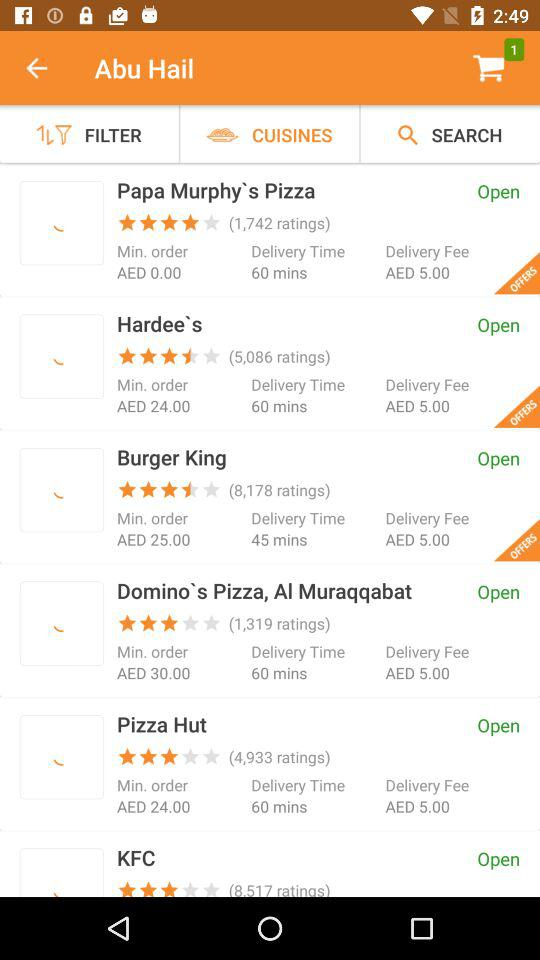How many items are there in the cart? There is 1 item. 